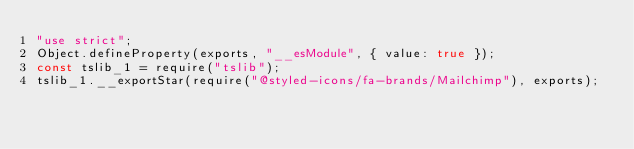<code> <loc_0><loc_0><loc_500><loc_500><_JavaScript_>"use strict";
Object.defineProperty(exports, "__esModule", { value: true });
const tslib_1 = require("tslib");
tslib_1.__exportStar(require("@styled-icons/fa-brands/Mailchimp"), exports);
</code> 